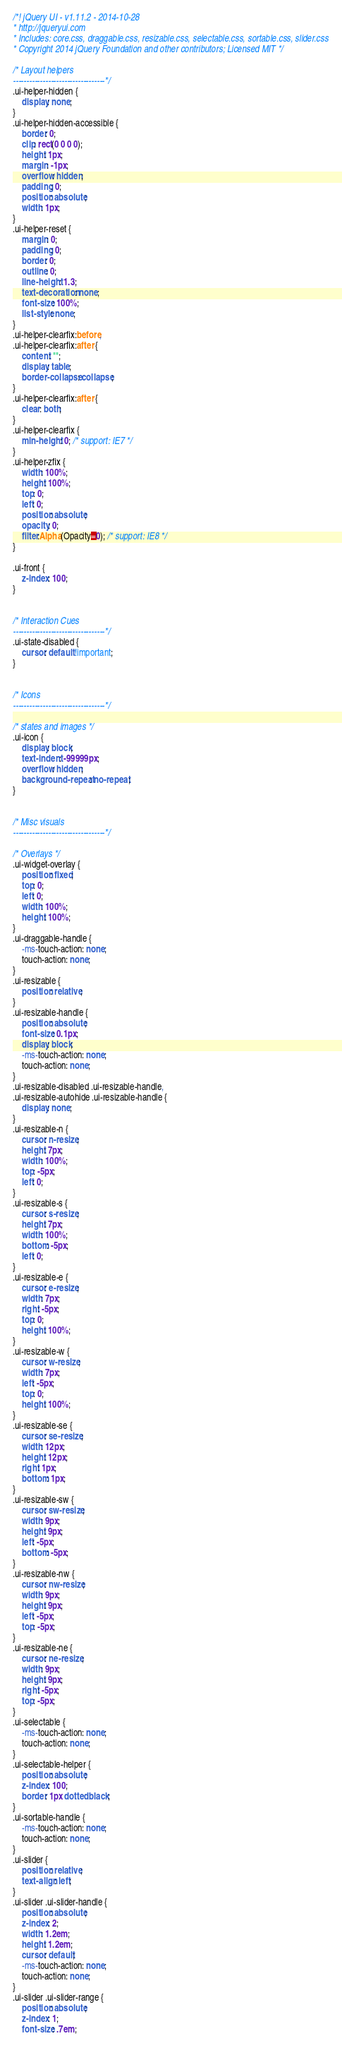<code> <loc_0><loc_0><loc_500><loc_500><_CSS_>/*! jQuery UI - v1.11.2 - 2014-10-28
* http://jqueryui.com
* Includes: core.css, draggable.css, resizable.css, selectable.css, sortable.css, slider.css
* Copyright 2014 jQuery Foundation and other contributors; Licensed MIT */

/* Layout helpers
----------------------------------*/
.ui-helper-hidden {
    display: none;
}
.ui-helper-hidden-accessible {
    border: 0;
    clip: rect(0 0 0 0);
    height: 1px;
    margin: -1px;
    overflow: hidden;
    padding: 0;
    position: absolute;
    width: 1px;
}
.ui-helper-reset {
    margin: 0;
    padding: 0;
    border: 0;
    outline: 0;
    line-height: 1.3;
    text-decoration: none;
    font-size: 100%;
    list-style: none;
}
.ui-helper-clearfix:before,
.ui-helper-clearfix:after {
    content: "";
    display: table;
    border-collapse: collapse;
}
.ui-helper-clearfix:after {
    clear: both;
}
.ui-helper-clearfix {
    min-height: 0; /* support: IE7 */
}
.ui-helper-zfix {
    width: 100%;
    height: 100%;
    top: 0;
    left: 0;
    position: absolute;
    opacity: 0;
    filter:Alpha(Opacity=0); /* support: IE8 */
}

.ui-front {
    z-index: 100;
}


/* Interaction Cues
----------------------------------*/
.ui-state-disabled {
    cursor: default !important;
}


/* Icons
----------------------------------*/

/* states and images */
.ui-icon {
    display: block;
    text-indent: -99999px;
    overflow: hidden;
    background-repeat: no-repeat;
}


/* Misc visuals
----------------------------------*/

/* Overlays */
.ui-widget-overlay {
    position: fixed;
    top: 0;
    left: 0;
    width: 100%;
    height: 100%;
}
.ui-draggable-handle {
    -ms-touch-action: none;
    touch-action: none;
}
.ui-resizable {
    position: relative;
}
.ui-resizable-handle {
    position: absolute;
    font-size: 0.1px;
    display: block;
    -ms-touch-action: none;
    touch-action: none;
}
.ui-resizable-disabled .ui-resizable-handle,
.ui-resizable-autohide .ui-resizable-handle {
    display: none;
}
.ui-resizable-n {
    cursor: n-resize;
    height: 7px;
    width: 100%;
    top: -5px;
    left: 0;
}
.ui-resizable-s {
    cursor: s-resize;
    height: 7px;
    width: 100%;
    bottom: -5px;
    left: 0;
}
.ui-resizable-e {
    cursor: e-resize;
    width: 7px;
    right: -5px;
    top: 0;
    height: 100%;
}
.ui-resizable-w {
    cursor: w-resize;
    width: 7px;
    left: -5px;
    top: 0;
    height: 100%;
}
.ui-resizable-se {
    cursor: se-resize;
    width: 12px;
    height: 12px;
    right: 1px;
    bottom: 1px;
}
.ui-resizable-sw {
    cursor: sw-resize;
    width: 9px;
    height: 9px;
    left: -5px;
    bottom: -5px;
}
.ui-resizable-nw {
    cursor: nw-resize;
    width: 9px;
    height: 9px;
    left: -5px;
    top: -5px;
}
.ui-resizable-ne {
    cursor: ne-resize;
    width: 9px;
    height: 9px;
    right: -5px;
    top: -5px;
}
.ui-selectable {
    -ms-touch-action: none;
    touch-action: none;
}
.ui-selectable-helper {
    position: absolute;
    z-index: 100;
    border: 1px dotted black;
}
.ui-sortable-handle {
    -ms-touch-action: none;
    touch-action: none;
}
.ui-slider {
    position: relative;
    text-align: left;
}
.ui-slider .ui-slider-handle {
    position: absolute;
    z-index: 2;
    width: 1.2em;
    height: 1.2em;
    cursor: default;
    -ms-touch-action: none;
    touch-action: none;
}
.ui-slider .ui-slider-range {
    position: absolute;
    z-index: 1;
    font-size: .7em;</code> 